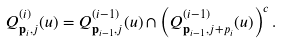<formula> <loc_0><loc_0><loc_500><loc_500>Q ^ { ( i ) } _ { \mathbf p _ { i } , j } ( u ) = Q ^ { ( i - 1 ) } _ { \mathbf p _ { i - 1 } , j } ( u ) \cap \left ( Q ^ { ( i - 1 ) } _ { \mathbf p _ { i - 1 } , j + p _ { i } } ( u ) \right ) ^ { c } .</formula> 